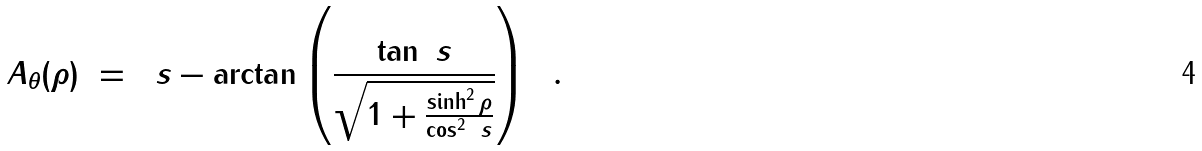<formula> <loc_0><loc_0><loc_500><loc_500>A _ { \theta } ( \rho ) \ = \ \ s - \arctan \left ( \frac { \tan \ s } { \sqrt { 1 + \frac { \sinh ^ { 2 } \rho } { \cos ^ { 2 } \ s } } } \right ) \ \ .</formula> 